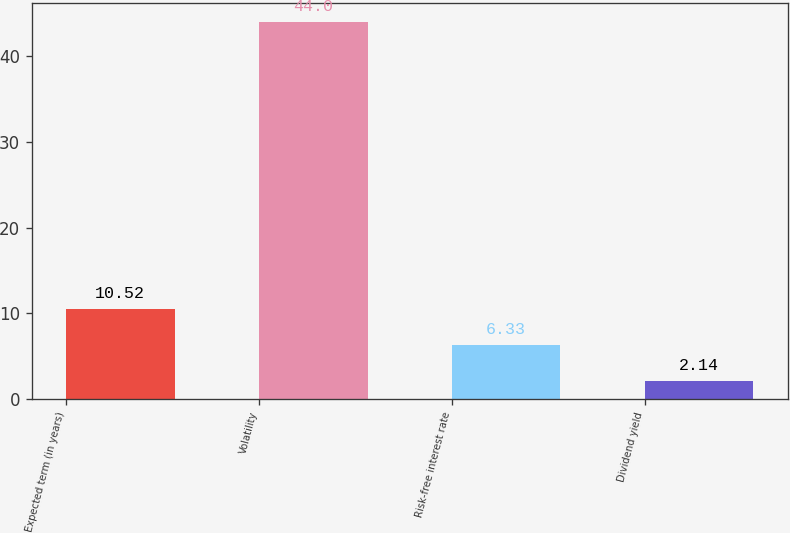Convert chart. <chart><loc_0><loc_0><loc_500><loc_500><bar_chart><fcel>Expected term (in years)<fcel>Volatility<fcel>Risk-free interest rate<fcel>Dividend yield<nl><fcel>10.52<fcel>44<fcel>6.33<fcel>2.14<nl></chart> 